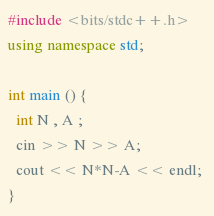Convert code to text. <code><loc_0><loc_0><loc_500><loc_500><_C++_>#include <bits/stdc++.h>
using namespace std;

int main () {
  int N , A ;
  cin >> N >> A;
  cout << N*N-A << endl; 
}
</code> 